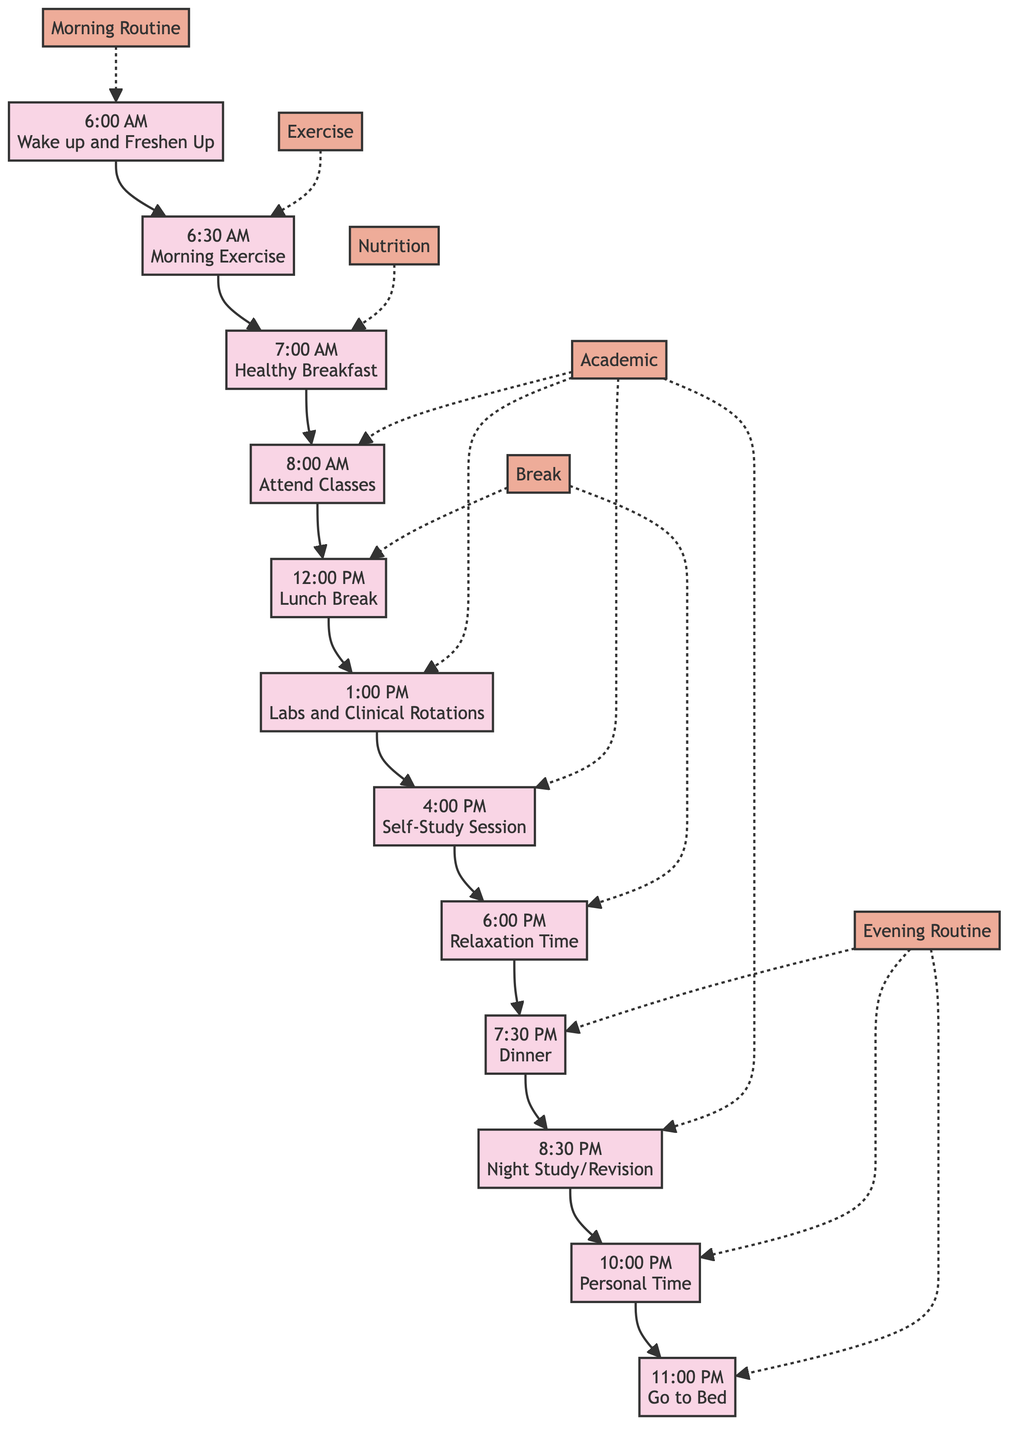What's the first activity in the daily routine? The diagram starts with the first activity labeled "Wake up and Freshen Up" at 6:00 AM, indicating that it is the initial step in the daily routine.
Answer: Wake up and Freshen Up How many activities are there in total? By counting each unique activity node in the diagram, we find that there are a total of 12 activities listed.
Answer: 12 What time does the study session occur? In the diagram, there is a Self-Study Session indicated at 4:00 PM, which is the designated time for studying.
Answer: 4:00 PM Which activity follows after dinner? When examining the flow, the activity that comes after "Dinner" at 7:30 PM is "Night Study/Revision" at 8:30 PM.
Answer: Night Study/Revision What is the time allocated for morning exercise? The diagram clearly states that the "Morning Exercise" is scheduled for 6:30 AM, indicating a 30-minute slot for this activity.
Answer: 6:30 AM Name one relaxation activity mentioned in the daily routine. The routine indicates "Relaxation Time" at 6:00 PM as a designated time to relax, chat with friends, or read.
Answer: Relaxation Time What activity is scheduled right before bed? The last activity in the routine, right before going to bed at 11:00 PM, is "Night Study/Revision" which occurs at 8:30 PM.
Answer: Night Study/Revision Where are the classes held? The diagram specifies that classes take place at "Moti Lal Nehru Medical College," which is where the medical student attends lectures and practical sessions.
Answer: Moti Lal Nehru Medical College What is included in a healthy breakfast? In the details for the breakfast activity at 7:00 AM, it mentions having "oatmeal, fruits, and a glass of milk," which comprises the healthy breakfast options.
Answer: Oatmeal, fruits, and a glass of milk 